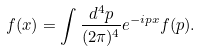Convert formula to latex. <formula><loc_0><loc_0><loc_500><loc_500>f ( x ) = \int \frac { d ^ { 4 } p } { ( 2 \pi ) ^ { 4 } } e ^ { - i p x } f ( p ) .</formula> 